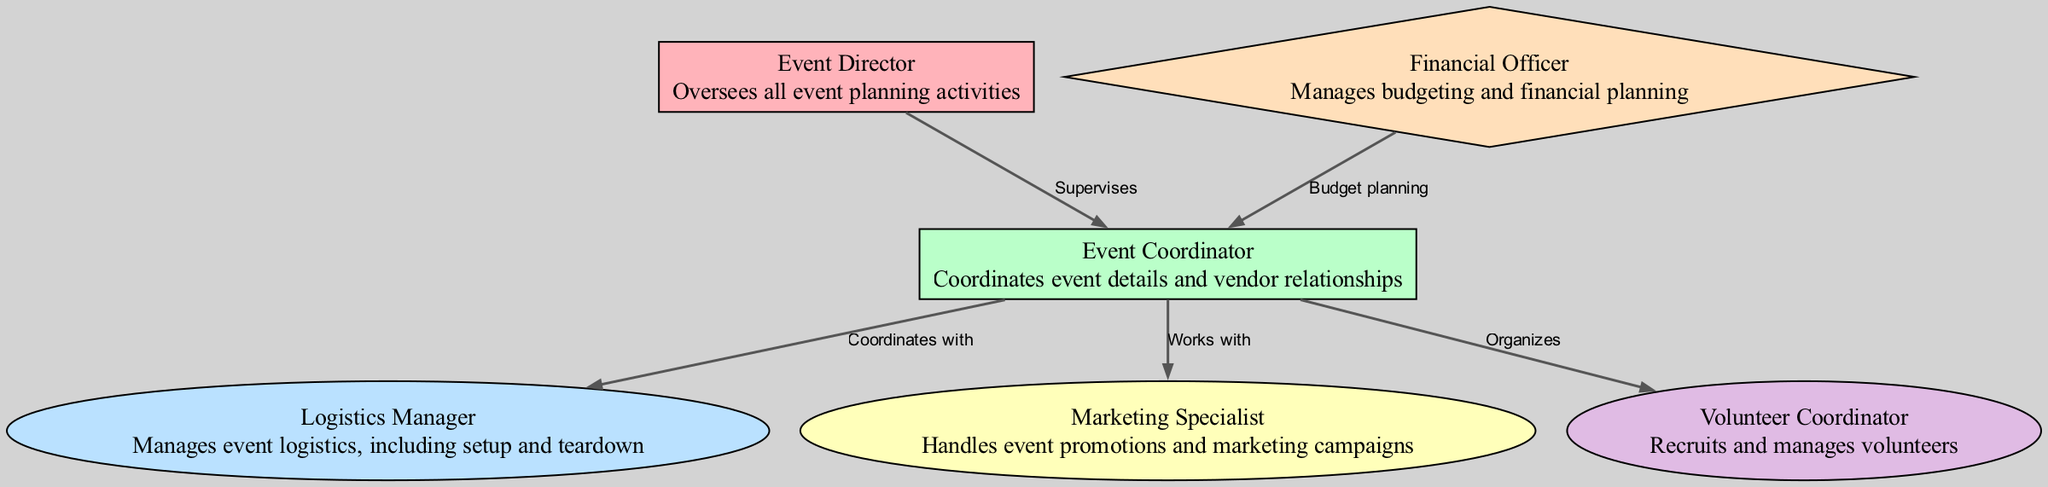What is the top position in the event planning team? The top position is represented by the node labeled "Event Director," which oversees all event planning activities, indicating its leadership role in the hierarchy.
Answer: Event Director How many roles are present in the diagram? Counting the nodes in the diagram, there are a total of six roles: Event Director, Event Coordinator, Logistics Manager, Marketing Specialist, Financial Officer, and Volunteer Coordinator.
Answer: Six Who does the Event Coordinator work with? The Event Coordinator collaborates with the Marketing Specialist and is also involved with the Logistics Manager and Volunteer Coordinator, but the question specifically asks for one entity; hence the primary work relationship is highlighted with the Marketing Specialist.
Answer: Marketing Specialist What role is responsible for budget planning? The edge labeled "Budget planning" points from Financial Officer to Event Coordinator, indicating that the Financial Officer is responsible for this task within the team.
Answer: Financial Officer How many edges indicate a supervisory relationship in the diagram? Examining the edges, there is one edge representing a supervisory relationship; the Event Director supervises the Event Coordinator. Thus, this is the only direct supervisory relationship depicted.
Answer: One What shape is used for the Volunteer Coordinator node? The diagram uses an ellipse to represent the shape of the Volunteer Coordinator, making it visually distinct from roles that have different shapes, such as rectangles or diamonds.
Answer: Ellipse Which role organizes volunteers? The Volunteer Coordinator is specifically noted as the role that organizes volunteers based on the edge labeled "Organizes" which indicates the task associated with this position.
Answer: Volunteer Coordinator Who does the Logistics Manager coordinate with? The Event Coordinator coordinates with the Logistics Manager according to the edge labeled "Coordinates with," showing the direct relationship and collaboration between these two roles.
Answer: Event Coordinator What color represents the Financial Officer in the diagram? The Financial Officer is represented in a light orange color, specifically noted as "#FFDFBA" in the diagram's color scheme, visually distinguishing it from other roles.
Answer: Light orange 